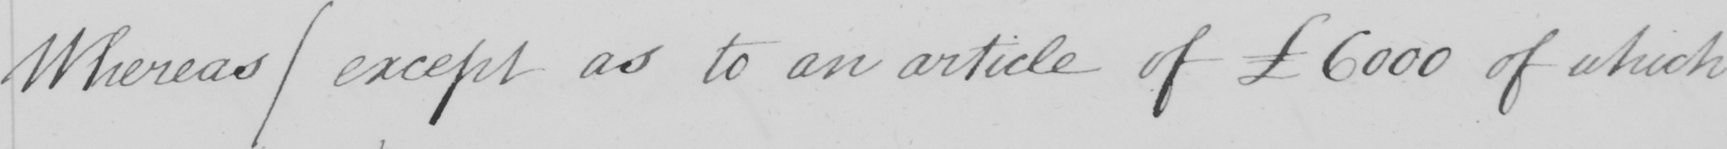Can you read and transcribe this handwriting? Whereas  (  except as to an article of £6000 of which 